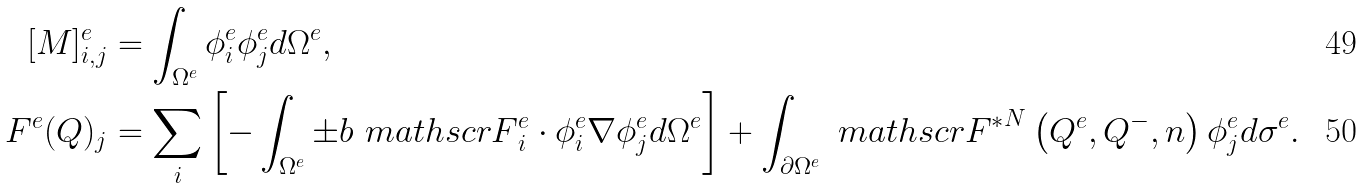<formula> <loc_0><loc_0><loc_500><loc_500>[ M ] ^ { e } _ { i , j } & = \int _ { \Omega ^ { e } } \phi ^ { e } _ { i } \phi ^ { e } _ { j } d \Omega ^ { e } , \\ F ^ { e } ( Q ) _ { j } & = \sum _ { i } \left [ - \int _ { \Omega ^ { e } } \pm b { \ m a t h s c r { F } } _ { i } ^ { e } \cdot \phi ^ { e } _ { i } \nabla \phi ^ { e } _ { j } d \Omega ^ { e } \right ] + \int _ { \partial \Omega ^ { e } } { \ m a t h s c r { F } ^ { * } } ^ { N } \left ( Q ^ { e } , Q ^ { - } , n \right ) \phi ^ { e } _ { j } d \sigma ^ { e } .</formula> 